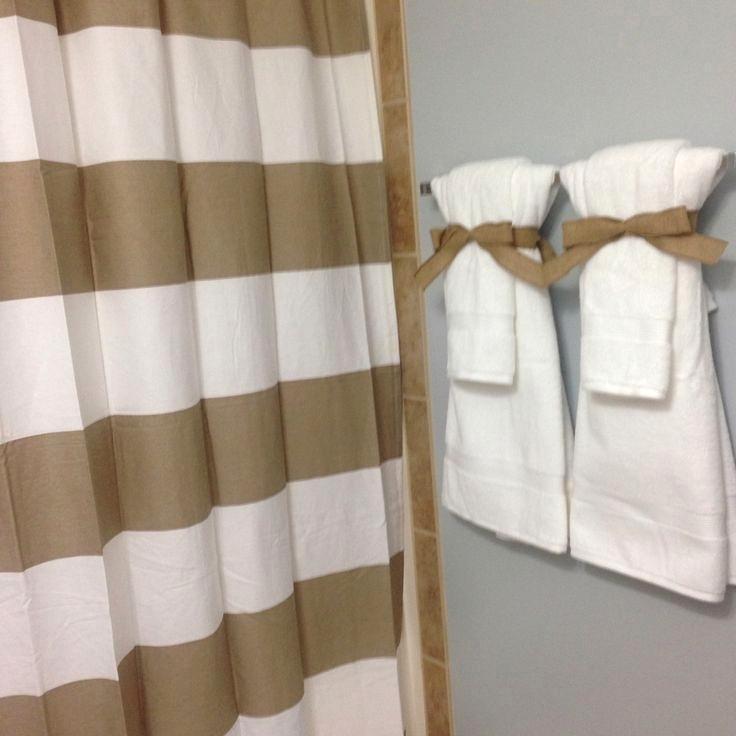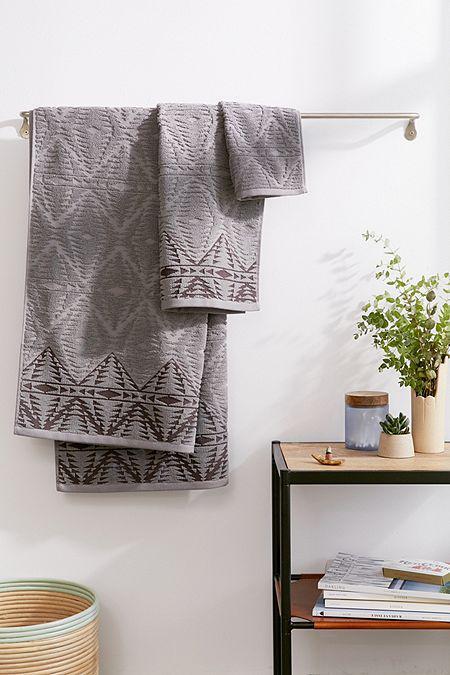The first image is the image on the left, the second image is the image on the right. Examine the images to the left and right. Is the description "One image features side-by-side white towels with smaller towels draped over them on a bar to the right of a shower." accurate? Answer yes or no. Yes. The first image is the image on the left, the second image is the image on the right. Given the left and right images, does the statement "In at  least one image there are two sets of hand towels next to a striped shower curtain." hold true? Answer yes or no. Yes. 